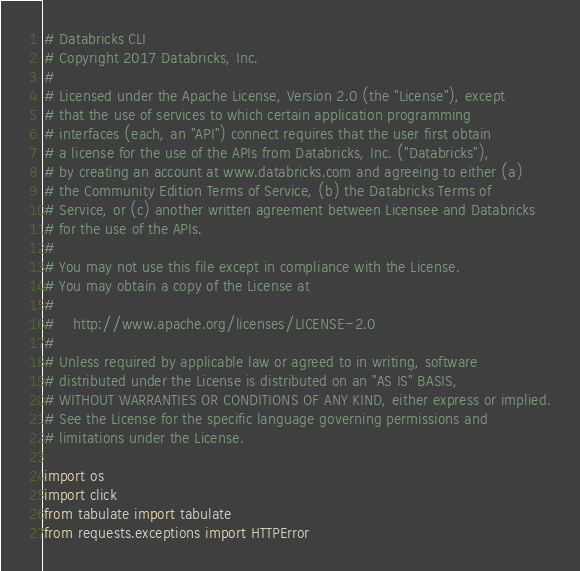<code> <loc_0><loc_0><loc_500><loc_500><_Python_># Databricks CLI
# Copyright 2017 Databricks, Inc.
#
# Licensed under the Apache License, Version 2.0 (the "License"), except
# that the use of services to which certain application programming
# interfaces (each, an "API") connect requires that the user first obtain
# a license for the use of the APIs from Databricks, Inc. ("Databricks"),
# by creating an account at www.databricks.com and agreeing to either (a)
# the Community Edition Terms of Service, (b) the Databricks Terms of
# Service, or (c) another written agreement between Licensee and Databricks
# for the use of the APIs.
#
# You may not use this file except in compliance with the License.
# You may obtain a copy of the License at
#
#    http://www.apache.org/licenses/LICENSE-2.0
#
# Unless required by applicable law or agreed to in writing, software
# distributed under the License is distributed on an "AS IS" BASIS,
# WITHOUT WARRANTIES OR CONDITIONS OF ANY KIND, either express or implied.
# See the License for the specific language governing permissions and
# limitations under the License.

import os
import click
from tabulate import tabulate
from requests.exceptions import HTTPError
</code> 